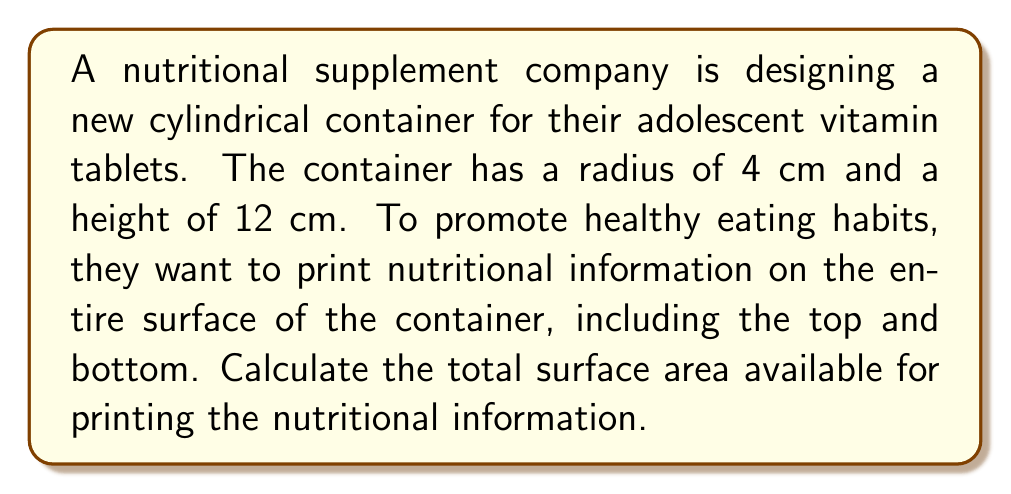Teach me how to tackle this problem. To solve this problem, we need to calculate the surface area of a cylinder, which consists of two circular bases and the lateral surface.

1. Calculate the area of one circular base:
   $$A_{base} = \pi r^2 = \pi (4\text{ cm})^2 = 16\pi\text{ cm}^2$$

2. Calculate the area of two circular bases:
   $$A_{two bases} = 2 \times 16\pi\text{ cm}^2 = 32\pi\text{ cm}^2$$

3. Calculate the lateral surface area (rectangle wrapped around the cylinder):
   $$A_{lateral} = 2\pi rh = 2\pi (4\text{ cm})(12\text{ cm}) = 96\pi\text{ cm}^2$$

4. Sum up the total surface area:
   $$A_{total} = A_{two bases} + A_{lateral} = 32\pi\text{ cm}^2 + 96\pi\text{ cm}^2 = 128\pi\text{ cm}^2$$

[asy]
import geometry;

size(200);
real r = 4;
real h = 12;

path p = (0,0)--(0,h)--(2r,h)--(2r,0)--cycle;
path q = ellipse((r,0),r,r/4);
path s = ellipse((r,h),r,r/4);

draw(surface(p),paleblue+opacity(0.5));
draw(p);
draw(q);
draw(s);
draw((0,0)--(0,h));
draw((2r,0)--(2r,h));

label("12 cm", (2r+0.5,h/2), E);
label("4 cm", (r,-1.5), S);

[/asy]
Answer: The total surface area available for printing nutritional information is $128\pi\text{ cm}^2$ or approximately $402.12\text{ cm}^2$. 